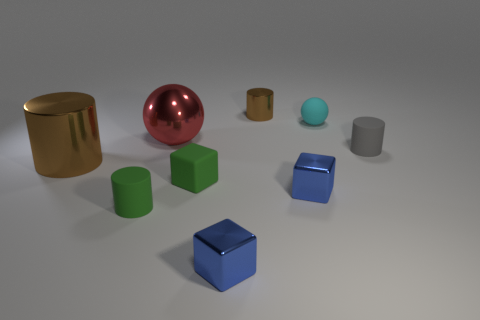There is a cyan rubber object; is its shape the same as the brown metallic object that is in front of the small gray matte cylinder?
Offer a terse response. No. The thing that is the same color as the large shiny cylinder is what size?
Give a very brief answer. Small. How many objects are either big green objects or blue shiny cubes?
Offer a terse response. 2. The brown thing in front of the shiny cylinder that is behind the small gray matte thing is what shape?
Keep it short and to the point. Cylinder. Does the tiny matte object behind the red sphere have the same shape as the gray thing?
Make the answer very short. No. What is the size of the cyan thing that is made of the same material as the tiny green cylinder?
Offer a terse response. Small. How many things are either small cylinders in front of the large cylinder or cylinders in front of the large red thing?
Ensure brevity in your answer.  3. Are there the same number of green rubber blocks to the right of the small brown metal object and tiny brown metal objects that are on the left side of the red thing?
Your answer should be compact. Yes. The tiny object on the right side of the cyan thing is what color?
Give a very brief answer. Gray. Do the small matte cube and the cylinder in front of the green matte block have the same color?
Provide a succinct answer. Yes. 